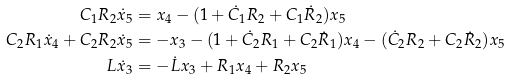Convert formula to latex. <formula><loc_0><loc_0><loc_500><loc_500>C _ { 1 } R _ { 2 } \dot { x } _ { 5 } & = x _ { 4 } - ( 1 + \dot { C } _ { 1 } R _ { 2 } + C _ { 1 } \dot { R } _ { 2 } ) x _ { 5 } \\ C _ { 2 } R _ { 1 } \dot { x } _ { 4 } + C _ { 2 } R _ { 2 } \dot { x } _ { 5 } & = - x _ { 3 } - ( 1 + \dot { C } _ { 2 } R _ { 1 } + C _ { 2 } \dot { R } _ { 1 } ) x _ { 4 } - ( \dot { C } _ { 2 } R _ { 2 } + C _ { 2 } \dot { R } _ { 2 } ) x _ { 5 } \\ L \dot { x } _ { 3 } & = - \dot { L } x _ { 3 } + R _ { 1 } x _ { 4 } + R _ { 2 } x _ { 5 }</formula> 